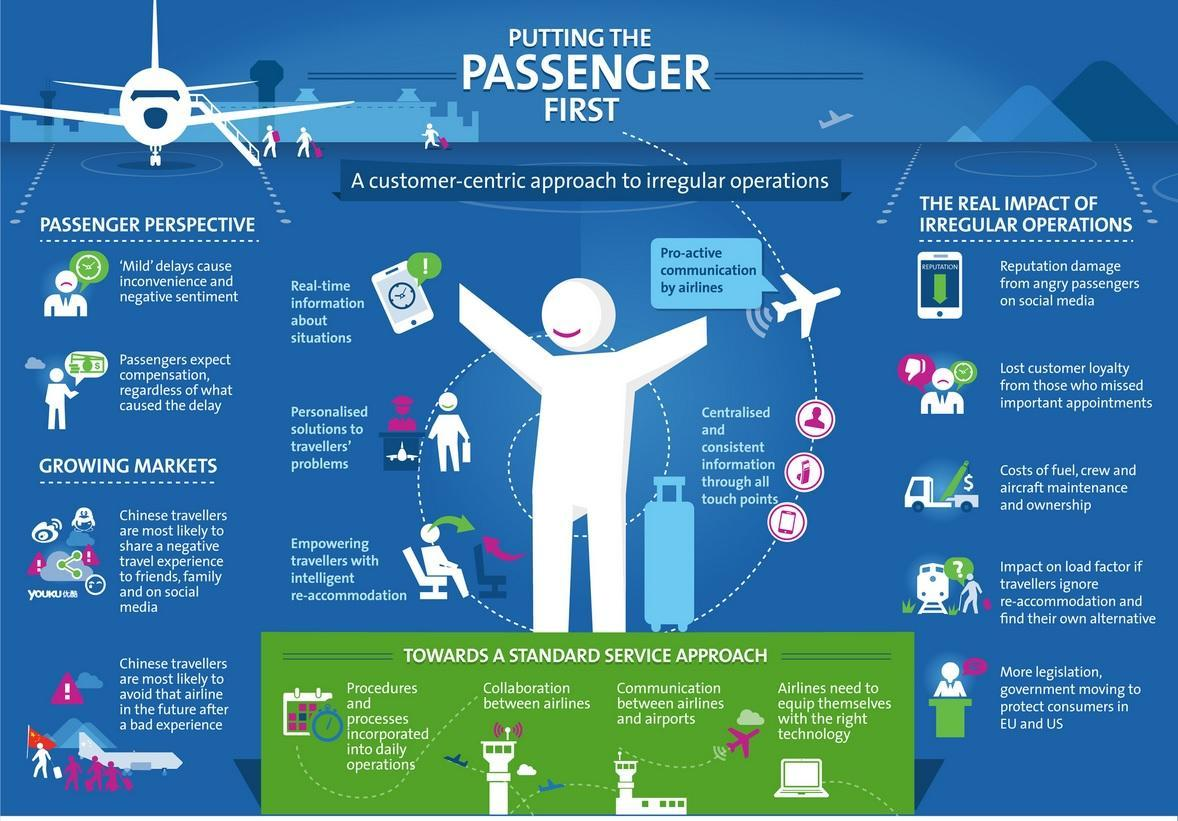How many points under the heading "Growing  Markets"?
Answer the question with a short phrase. 2 How many points under the heading "Passenger Perspective"? 2 